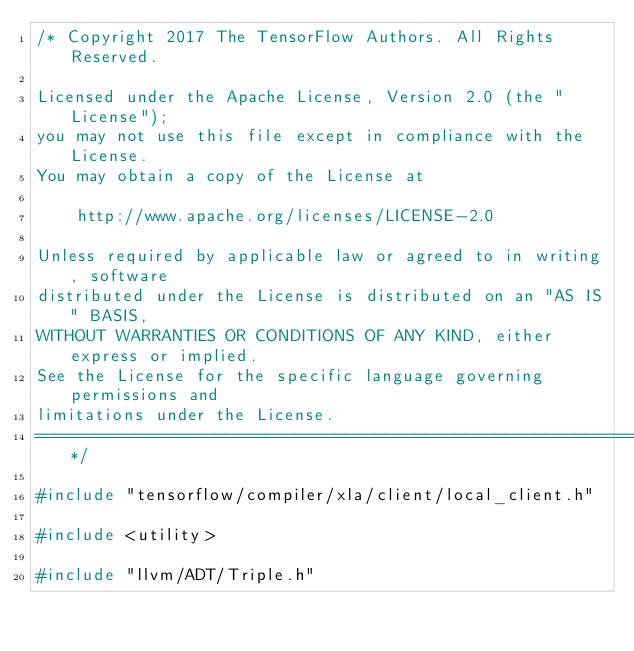Convert code to text. <code><loc_0><loc_0><loc_500><loc_500><_C++_>/* Copyright 2017 The TensorFlow Authors. All Rights Reserved.

Licensed under the Apache License, Version 2.0 (the "License");
you may not use this file except in compliance with the License.
You may obtain a copy of the License at

    http://www.apache.org/licenses/LICENSE-2.0

Unless required by applicable law or agreed to in writing, software
distributed under the License is distributed on an "AS IS" BASIS,
WITHOUT WARRANTIES OR CONDITIONS OF ANY KIND, either express or implied.
See the License for the specific language governing permissions and
limitations under the License.
==============================================================================*/

#include "tensorflow/compiler/xla/client/local_client.h"

#include <utility>

#include "llvm/ADT/Triple.h"</code> 